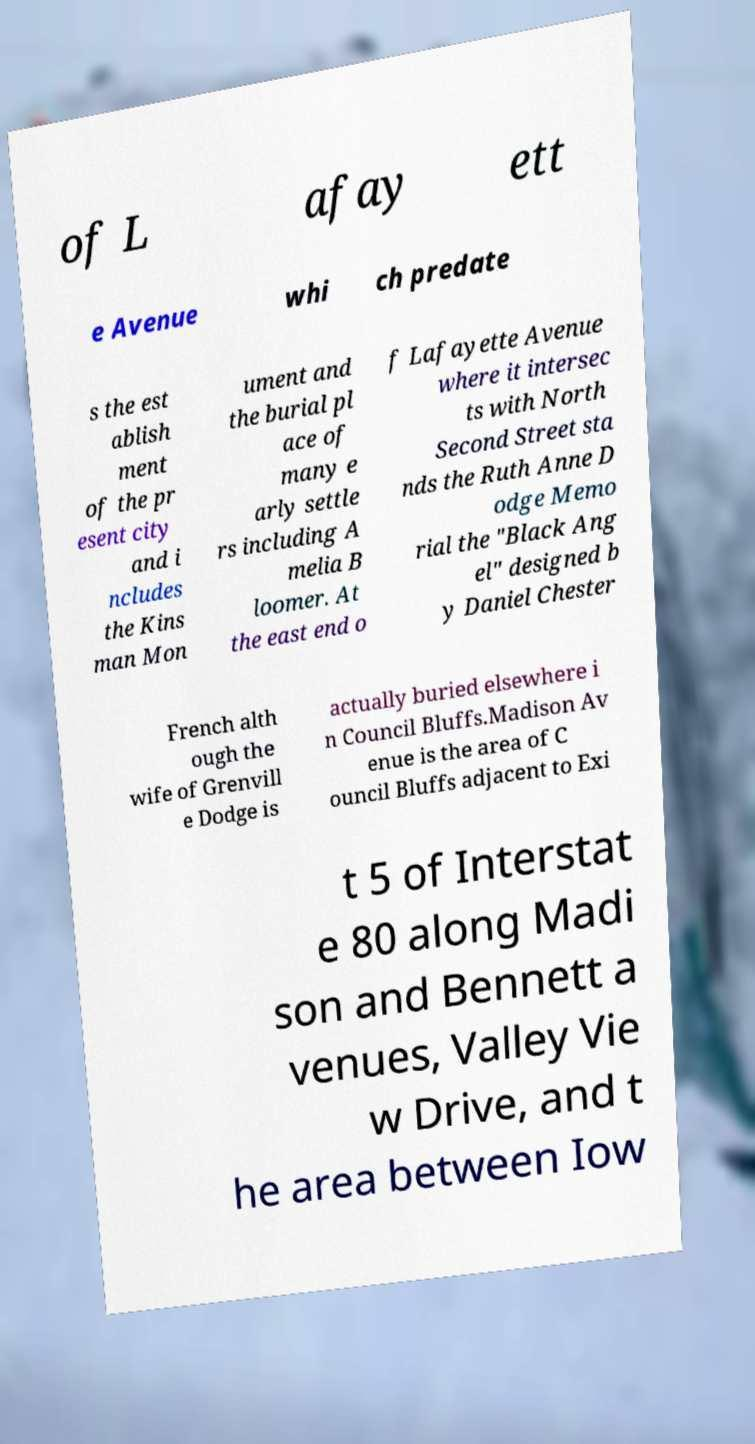What messages or text are displayed in this image? I need them in a readable, typed format. of L afay ett e Avenue whi ch predate s the est ablish ment of the pr esent city and i ncludes the Kins man Mon ument and the burial pl ace of many e arly settle rs including A melia B loomer. At the east end o f Lafayette Avenue where it intersec ts with North Second Street sta nds the Ruth Anne D odge Memo rial the "Black Ang el" designed b y Daniel Chester French alth ough the wife of Grenvill e Dodge is actually buried elsewhere i n Council Bluffs.Madison Av enue is the area of C ouncil Bluffs adjacent to Exi t 5 of Interstat e 80 along Madi son and Bennett a venues, Valley Vie w Drive, and t he area between Iow 